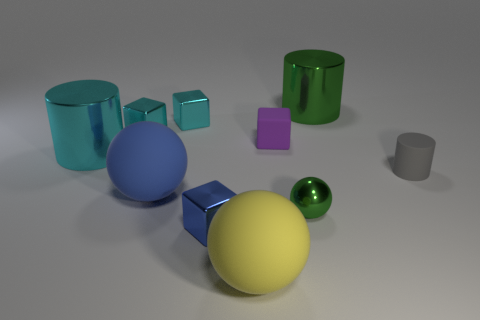Can you describe the atmosphere or mood the image conveys? The image has a calm and orderly atmosphere, with its neatly arranged objects and soft lighting. The muted floor and background don't compete for attention, which allows the viewer to focus on the colors and shapes of the objects, creating a tranquil and contemplative mood. 